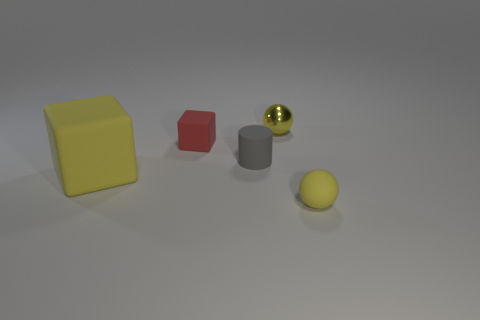Do the matte thing that is on the left side of the red rubber block and the sphere that is behind the large yellow cube have the same size?
Your response must be concise. No. How many large blocks are the same material as the small gray cylinder?
Keep it short and to the point. 1. There is a yellow ball behind the small thing that is to the right of the tiny shiny sphere; what number of small metal objects are behind it?
Give a very brief answer. 0. Does the tiny gray object have the same shape as the tiny red matte thing?
Offer a terse response. No. Is there a big matte thing that has the same shape as the small red object?
Offer a terse response. Yes. What is the shape of the gray rubber thing that is the same size as the red cube?
Your answer should be compact. Cylinder. What material is the small sphere in front of the yellow ball behind the matte cube that is behind the big rubber block made of?
Your response must be concise. Rubber. Does the yellow metal sphere have the same size as the yellow rubber block?
Provide a short and direct response. No. What is the material of the small cylinder?
Keep it short and to the point. Rubber. What is the material of the tiny object that is the same color as the tiny rubber sphere?
Your response must be concise. Metal. 